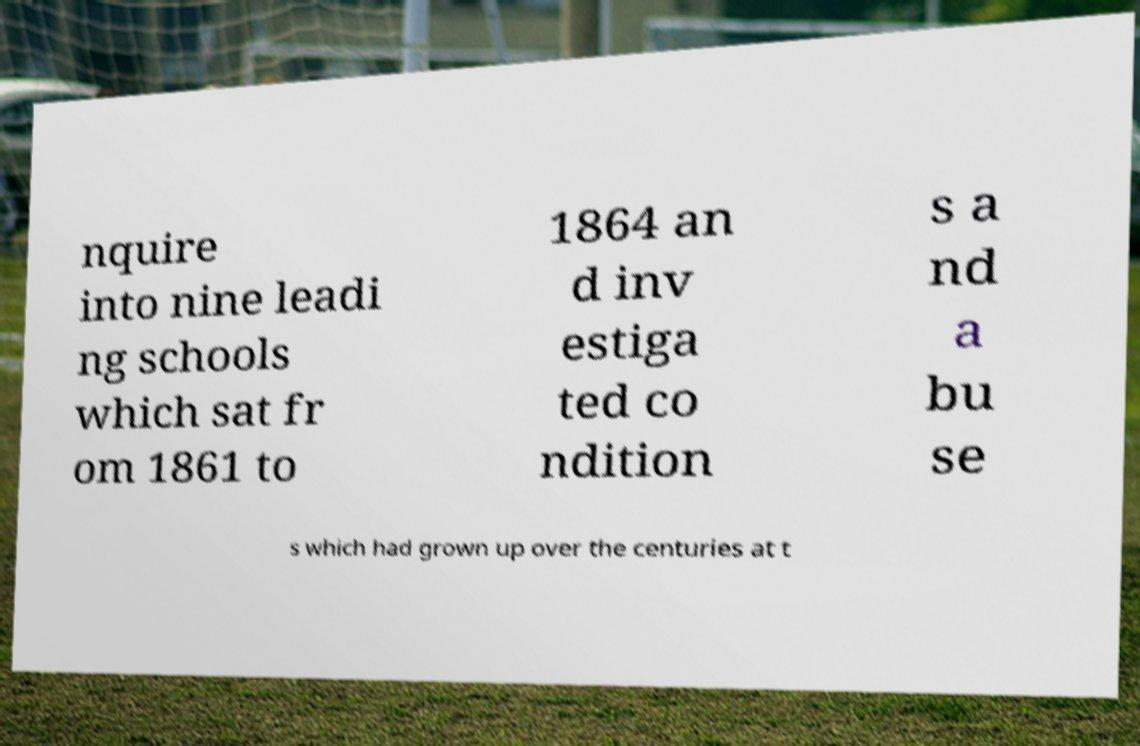What messages or text are displayed in this image? I need them in a readable, typed format. nquire into nine leadi ng schools which sat fr om 1861 to 1864 an d inv estiga ted co ndition s a nd a bu se s which had grown up over the centuries at t 